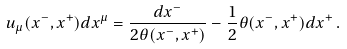<formula> <loc_0><loc_0><loc_500><loc_500>u _ { \mu } ( x ^ { - } , x ^ { + } ) d x ^ { \mu } = \frac { d x ^ { - } } { 2 \theta ( x ^ { - } , x ^ { + } ) } - \frac { 1 } { 2 } \theta ( x ^ { - } , x ^ { + } ) d x ^ { + } \, .</formula> 